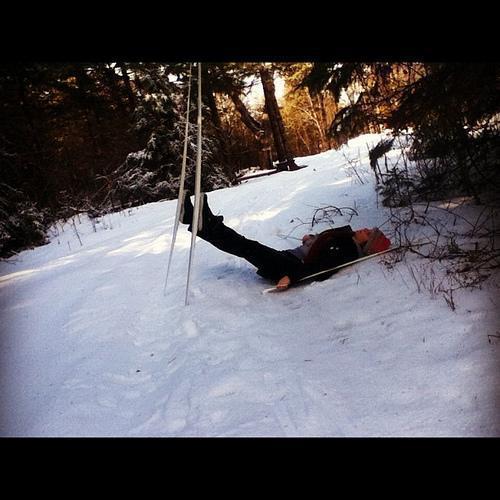How many people are there?
Give a very brief answer. 1. 